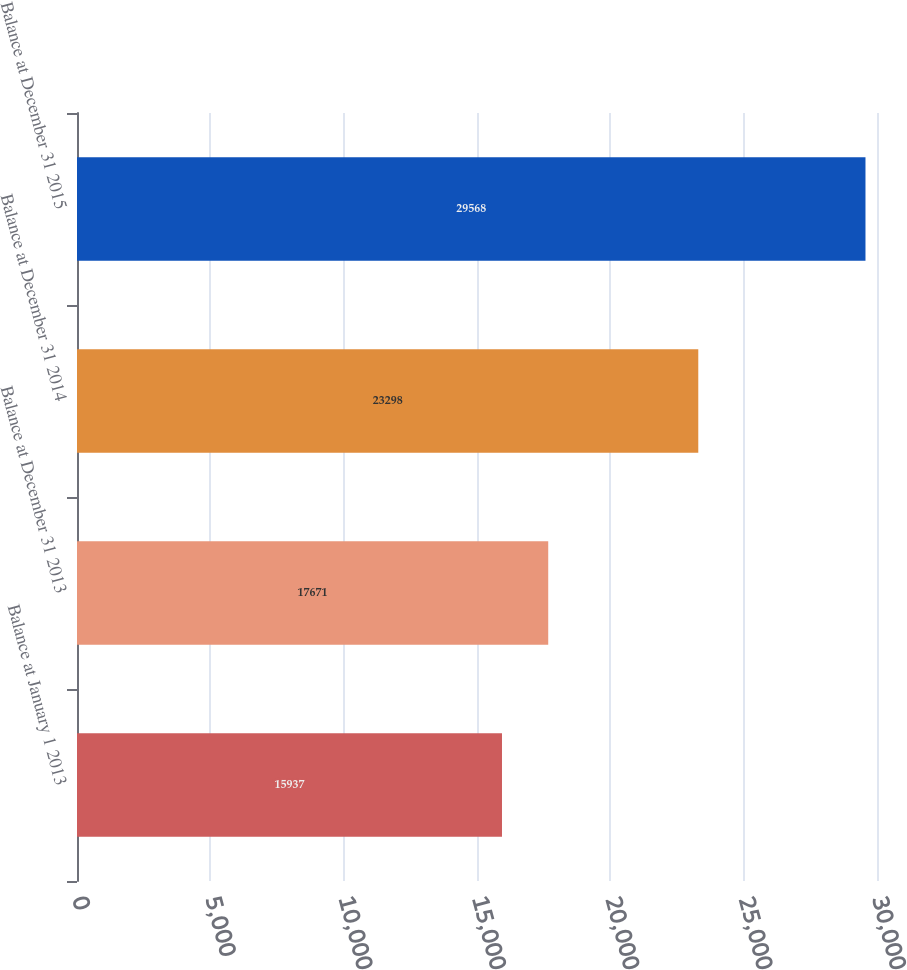Convert chart to OTSL. <chart><loc_0><loc_0><loc_500><loc_500><bar_chart><fcel>Balance at January 1 2013<fcel>Balance at December 31 2013<fcel>Balance at December 31 2014<fcel>Balance at December 31 2015<nl><fcel>15937<fcel>17671<fcel>23298<fcel>29568<nl></chart> 